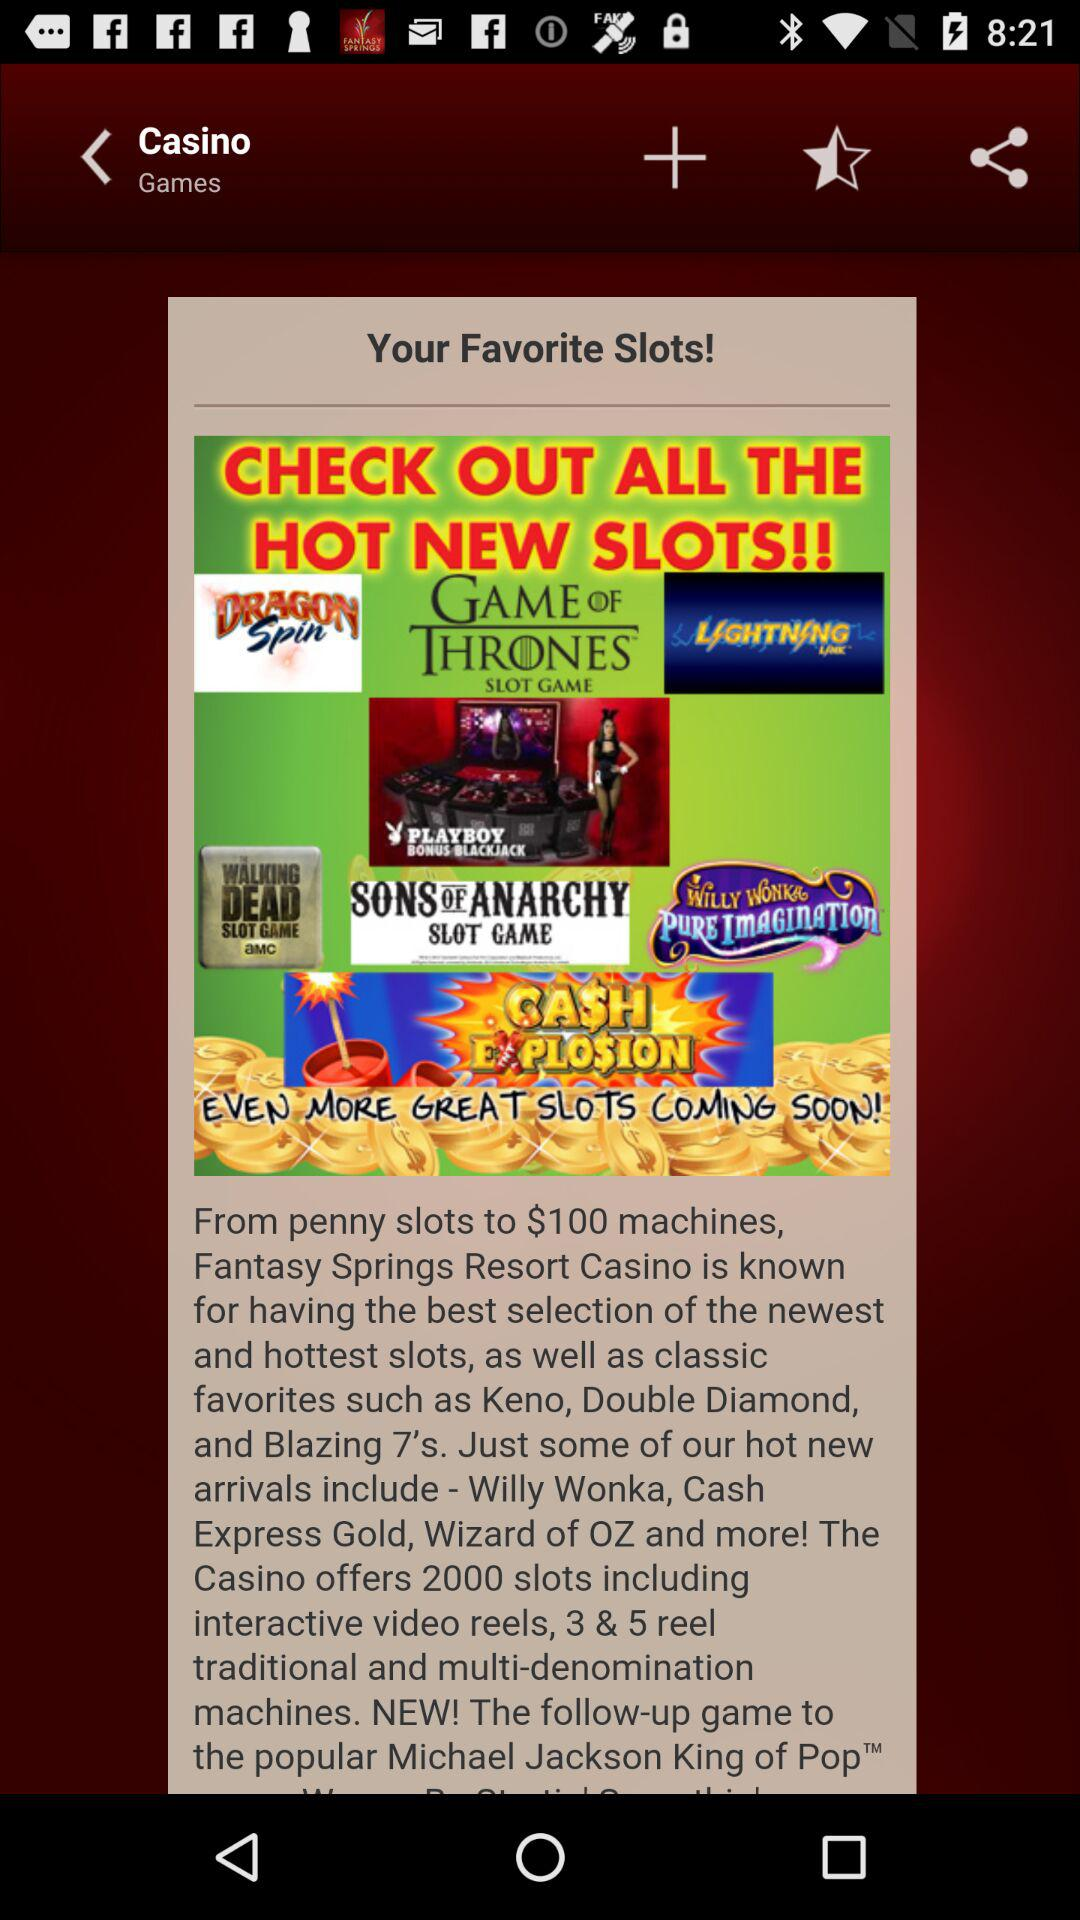What is the game name? The game name is "Casino". 